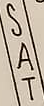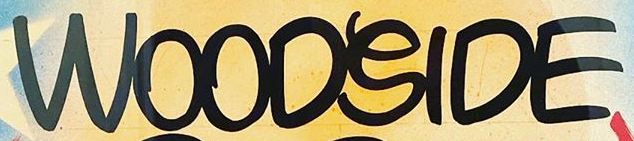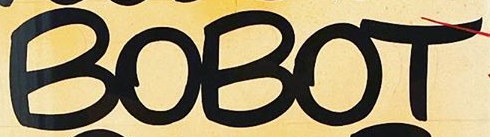What text appears in these images from left to right, separated by a semicolon? SAT; WOODSIDE; BOBOT 